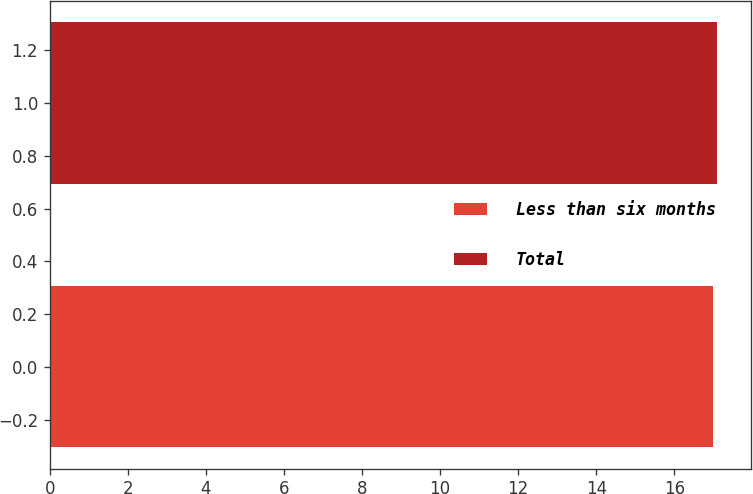Convert chart. <chart><loc_0><loc_0><loc_500><loc_500><bar_chart><fcel>Less than six months<fcel>Total<nl><fcel>17<fcel>17.1<nl></chart> 